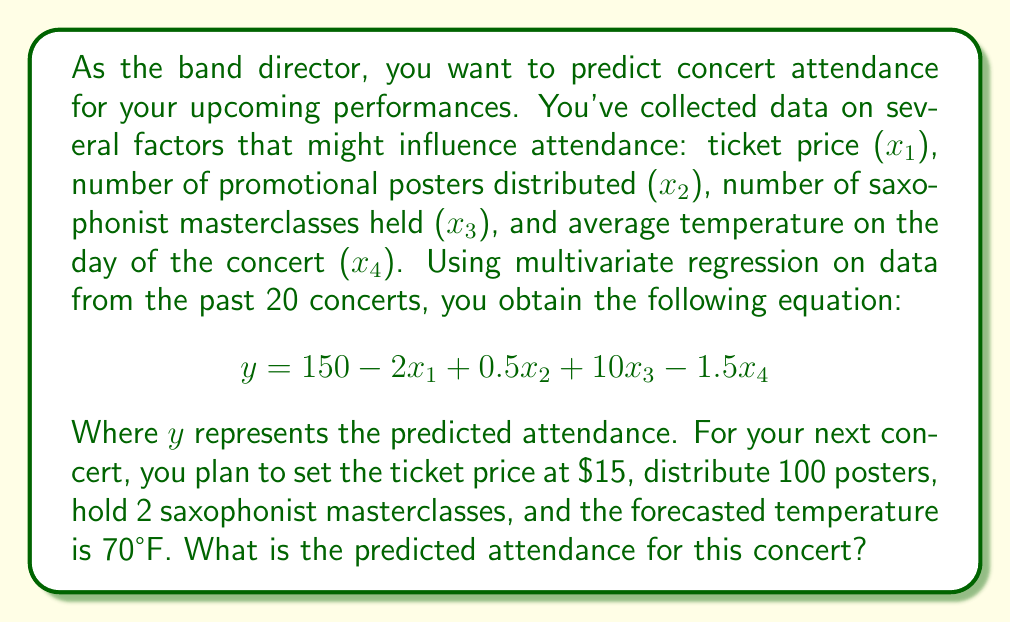Provide a solution to this math problem. To solve this problem, we need to use the given multivariate regression equation and plug in the values for each variable:

$$y = 150 - 2x_1 + 0.5x_2 + 10x_3 - 1.5x_4$$

Where:
$y$ = predicted attendance
$x_1$ = ticket price = $15
$x_2$ = number of promotional posters = 100
$x_3$ = number of saxophonist masterclasses = 2
$x_4$ = average temperature = 70°F

Let's substitute these values into the equation:

$$\begin{aligned}
y &= 150 - 2(15) + 0.5(100) + 10(2) - 1.5(70) \\
&= 150 - 30 + 50 + 20 - 105 \\
&= 85
\end{aligned}$$
Answer: The predicted attendance for the upcoming concert is 85 people. 